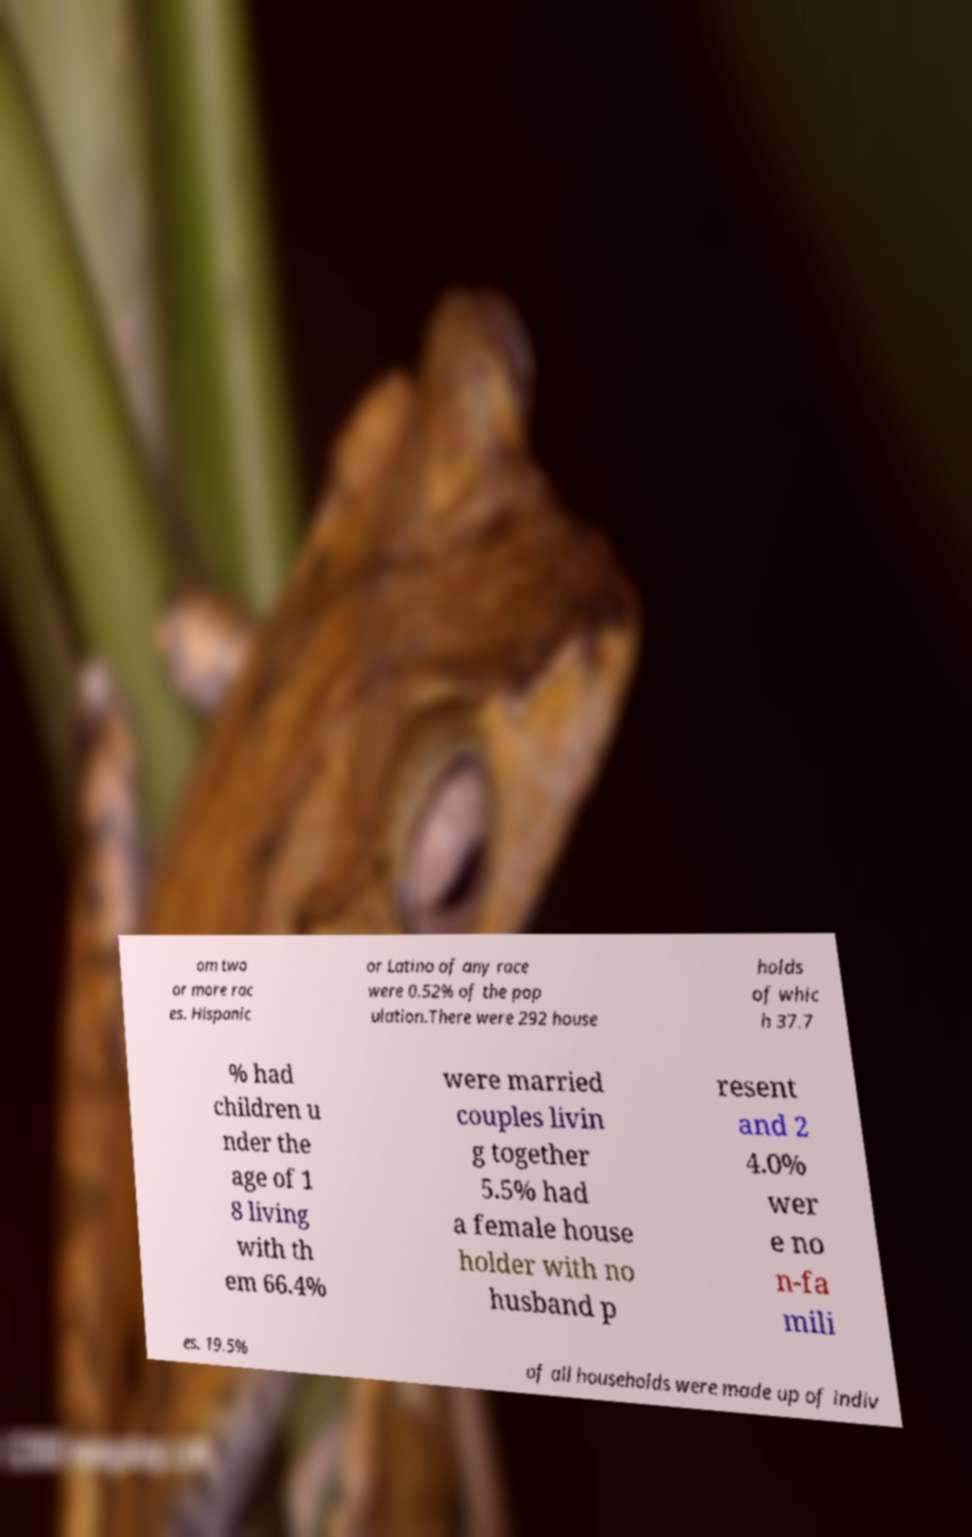For documentation purposes, I need the text within this image transcribed. Could you provide that? om two or more rac es. Hispanic or Latino of any race were 0.52% of the pop ulation.There were 292 house holds of whic h 37.7 % had children u nder the age of 1 8 living with th em 66.4% were married couples livin g together 5.5% had a female house holder with no husband p resent and 2 4.0% wer e no n-fa mili es. 19.5% of all households were made up of indiv 